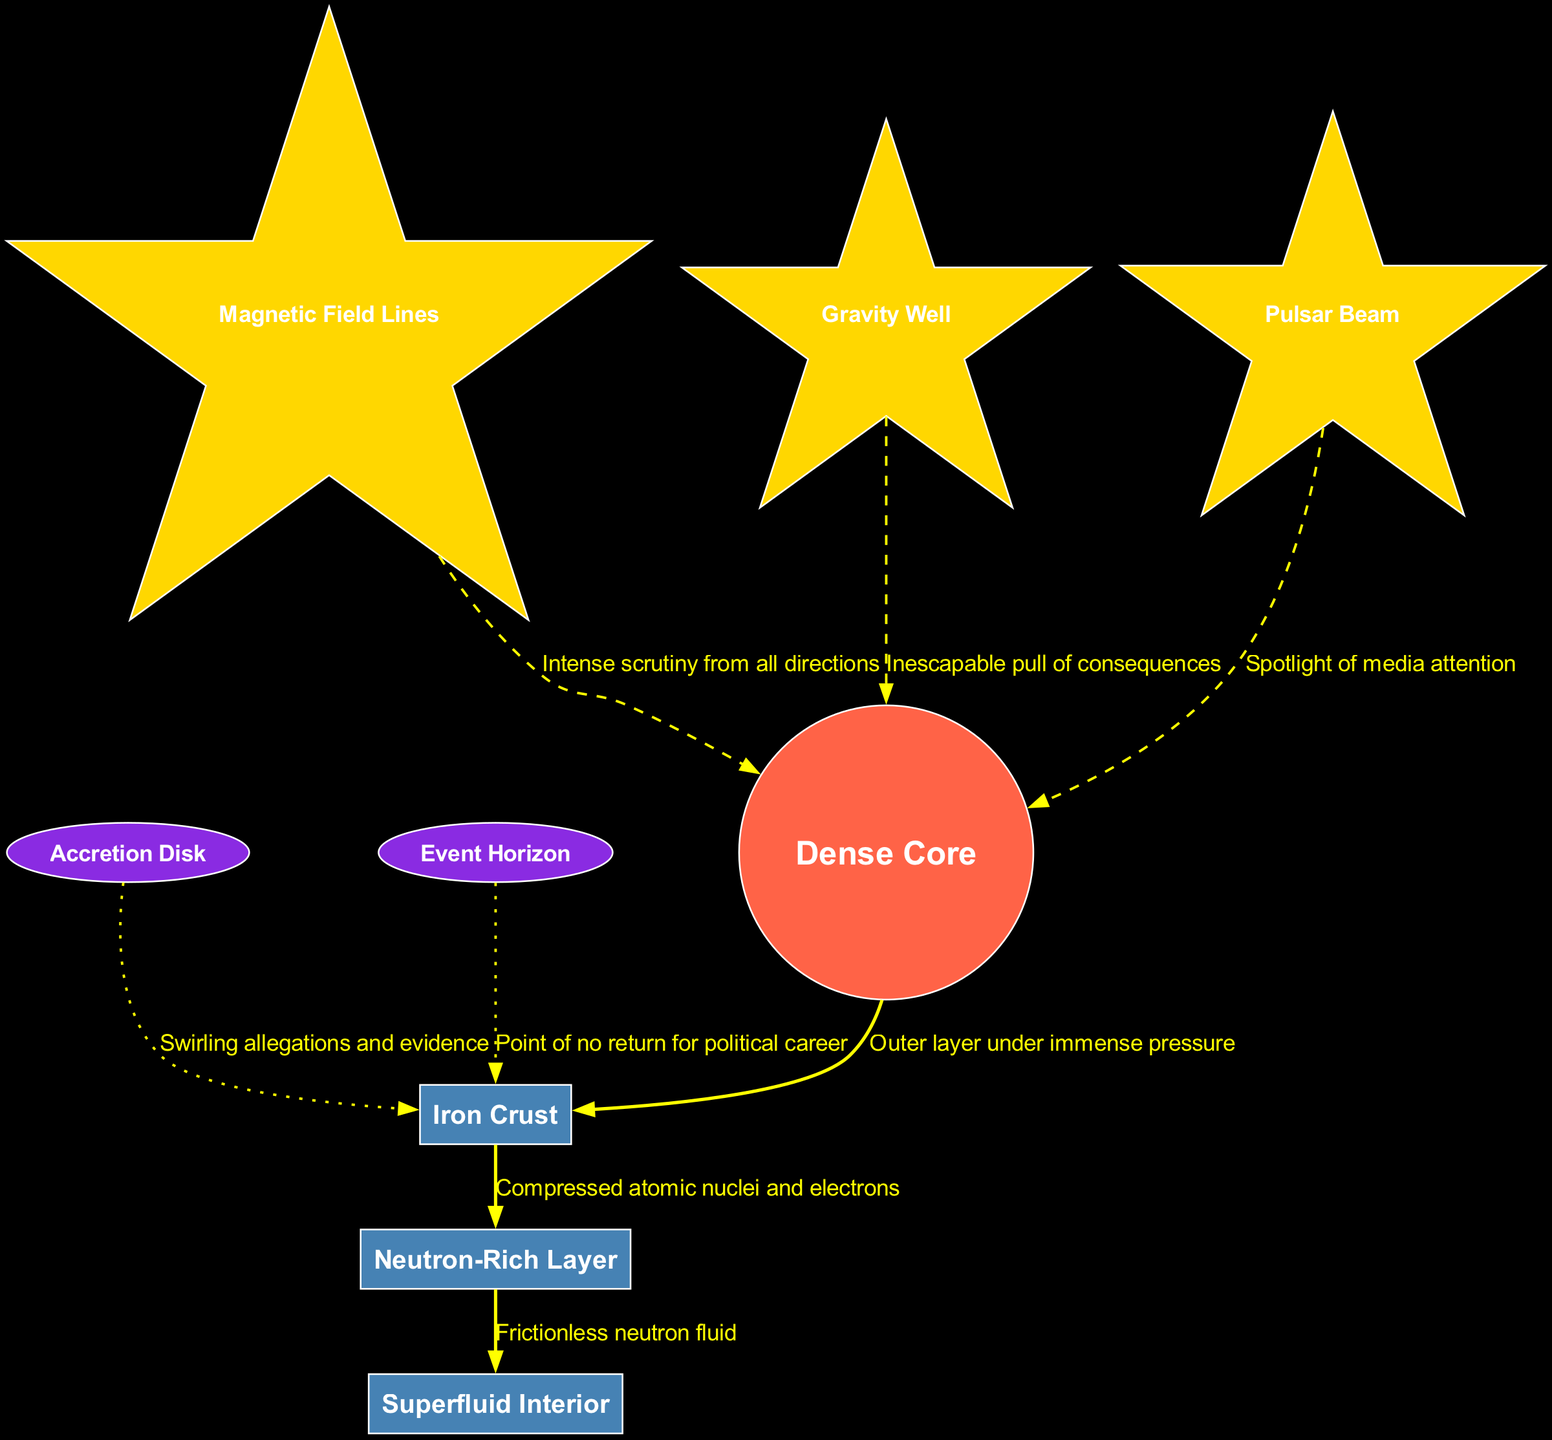What is the central element of the diagram? The diagram's central element is labeled as the "Dense Core", which can be identified within the visual representation.
Answer: Dense Core How many layers are shown in the diagram? The diagram contains three distinct layers: Iron Crust, Neutron-Rich Layer, and Superfluid Interior. This can be confirmed by counting the listed layers.
Answer: 3 What layer is under immense pressure? The "Iron Crust" layer is described as the outer layer under immense pressure, as indicated in the layer descriptions.
Answer: Iron Crust What are the magnetic field lines associated with? The "Magnetic Field Lines" feature represents the intense scrutiny, indicating public and media attention which surrounds the core of the neutron star.
Answer: Intense scrutiny Which features are connected to the core? The diagram connects three features to the core, namely Magnetic Field Lines, Gravity Well, and Pulsar Beam, showcasing scrutiny, consequences, and media attention, respectively.
Answer: 3 What is at the point of no return for the political career? The "Event Horizon" is labeled as the point of no return for the political career within the diagram.
Answer: Event Horizon Which surrounding element represents swirling allegations? The "Accretion Disk" is described as swirling allegations and evidence, thus representing the chaos surrounding the politician.
Answer: Accretion Disk What is the relationship between the layers and the central core? The layers (Iron Crust, Neutron-Rich Layer, Superfluid Interior) are all directly connected to the central "Dense Core", with edges indicating that they surround and support it.
Answer: Surrounded by layers What does the Pulsar Beam symbolize in the diagram? The "Pulsar Beam" is depicted as the spotlight of media attention, indicating focusing scrutiny on the core.
Answer: Spotlight of media attention 